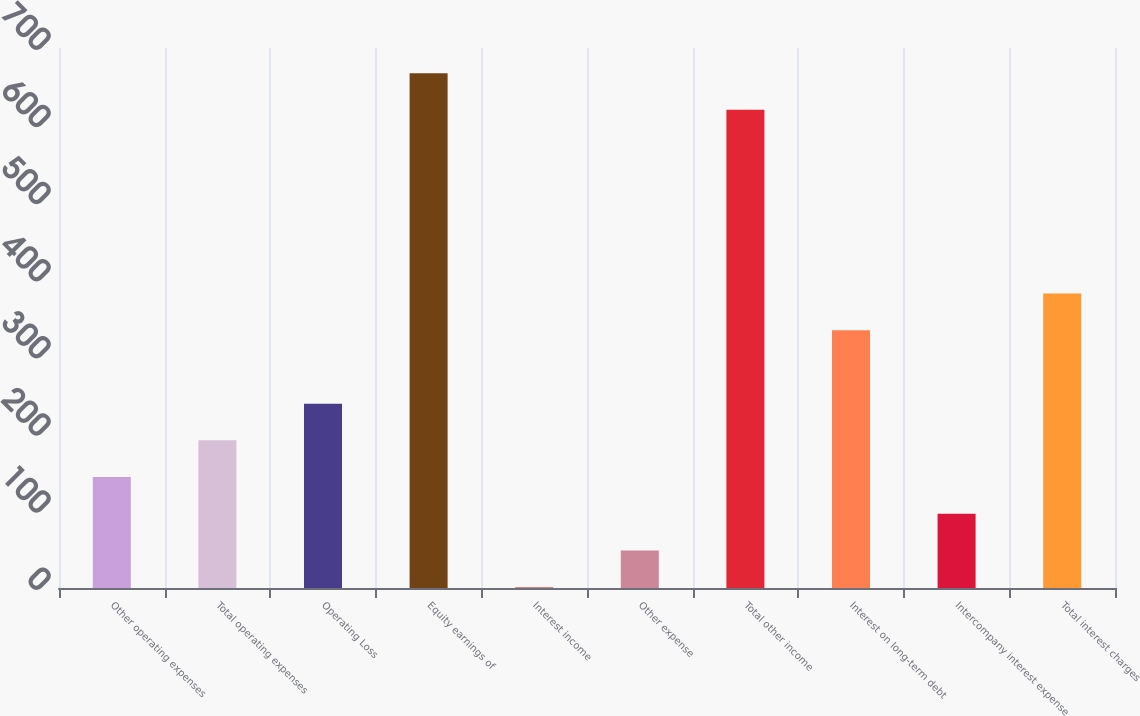Convert chart. <chart><loc_0><loc_0><loc_500><loc_500><bar_chart><fcel>Other operating expenses<fcel>Total operating expenses<fcel>Operating Loss<fcel>Equity earnings of<fcel>Interest income<fcel>Other expense<fcel>Total other income<fcel>Interest on long-term debt<fcel>Intercompany interest expense<fcel>Total interest charges<nl><fcel>143.8<fcel>191.4<fcel>239<fcel>667.4<fcel>1<fcel>48.6<fcel>619.8<fcel>334.2<fcel>96.2<fcel>381.8<nl></chart> 